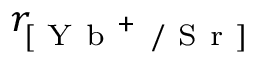<formula> <loc_0><loc_0><loc_500><loc_500>r _ { [ Y b ^ { + } / S r ] }</formula> 